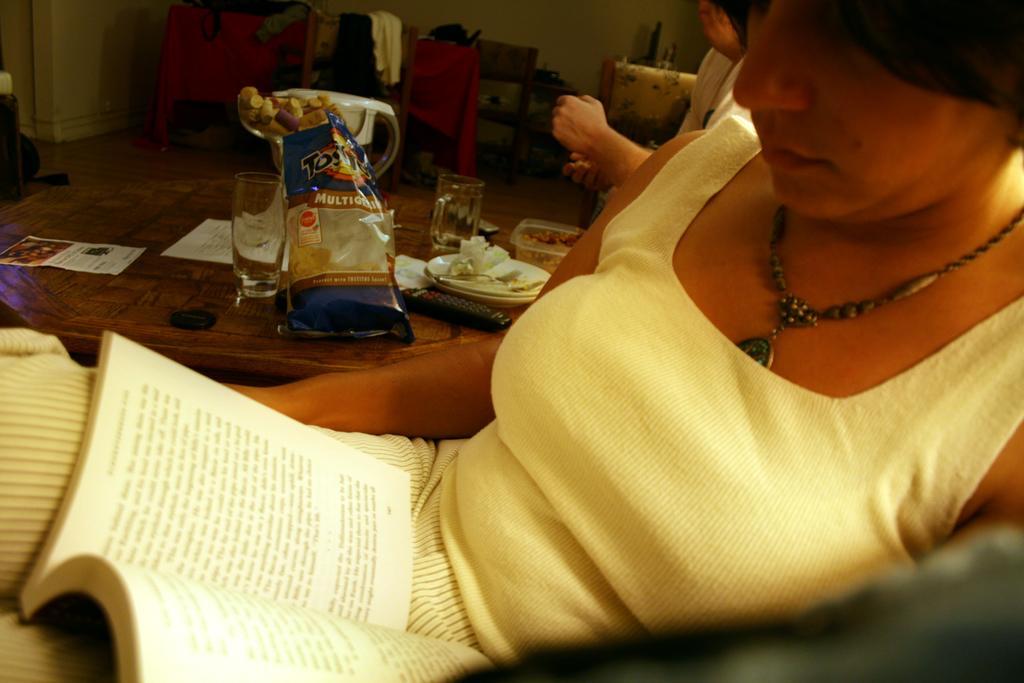In one or two sentences, can you explain what this image depicts? Here there is a woman sitting and looking at the book. Beside her there is a table on which food items,glass,papers,jar,plates,remote are held. In the background we clothes on the chair. 